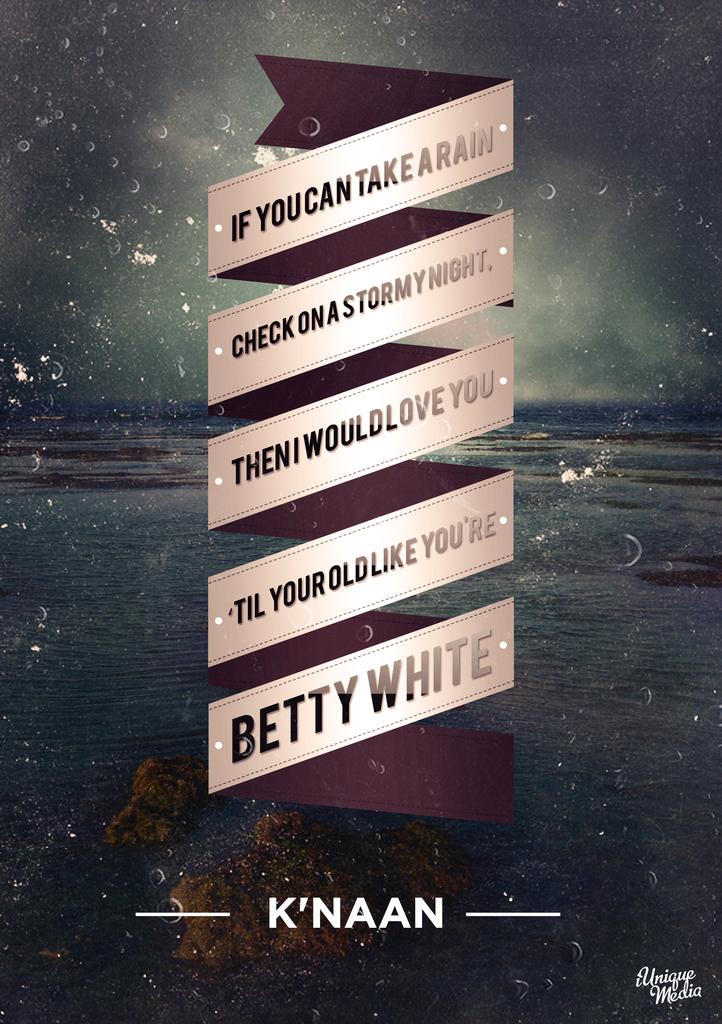What is the famous name on the banners in the middle?
Your answer should be compact. Betty white. What is this called?
Provide a short and direct response. K'naan. 